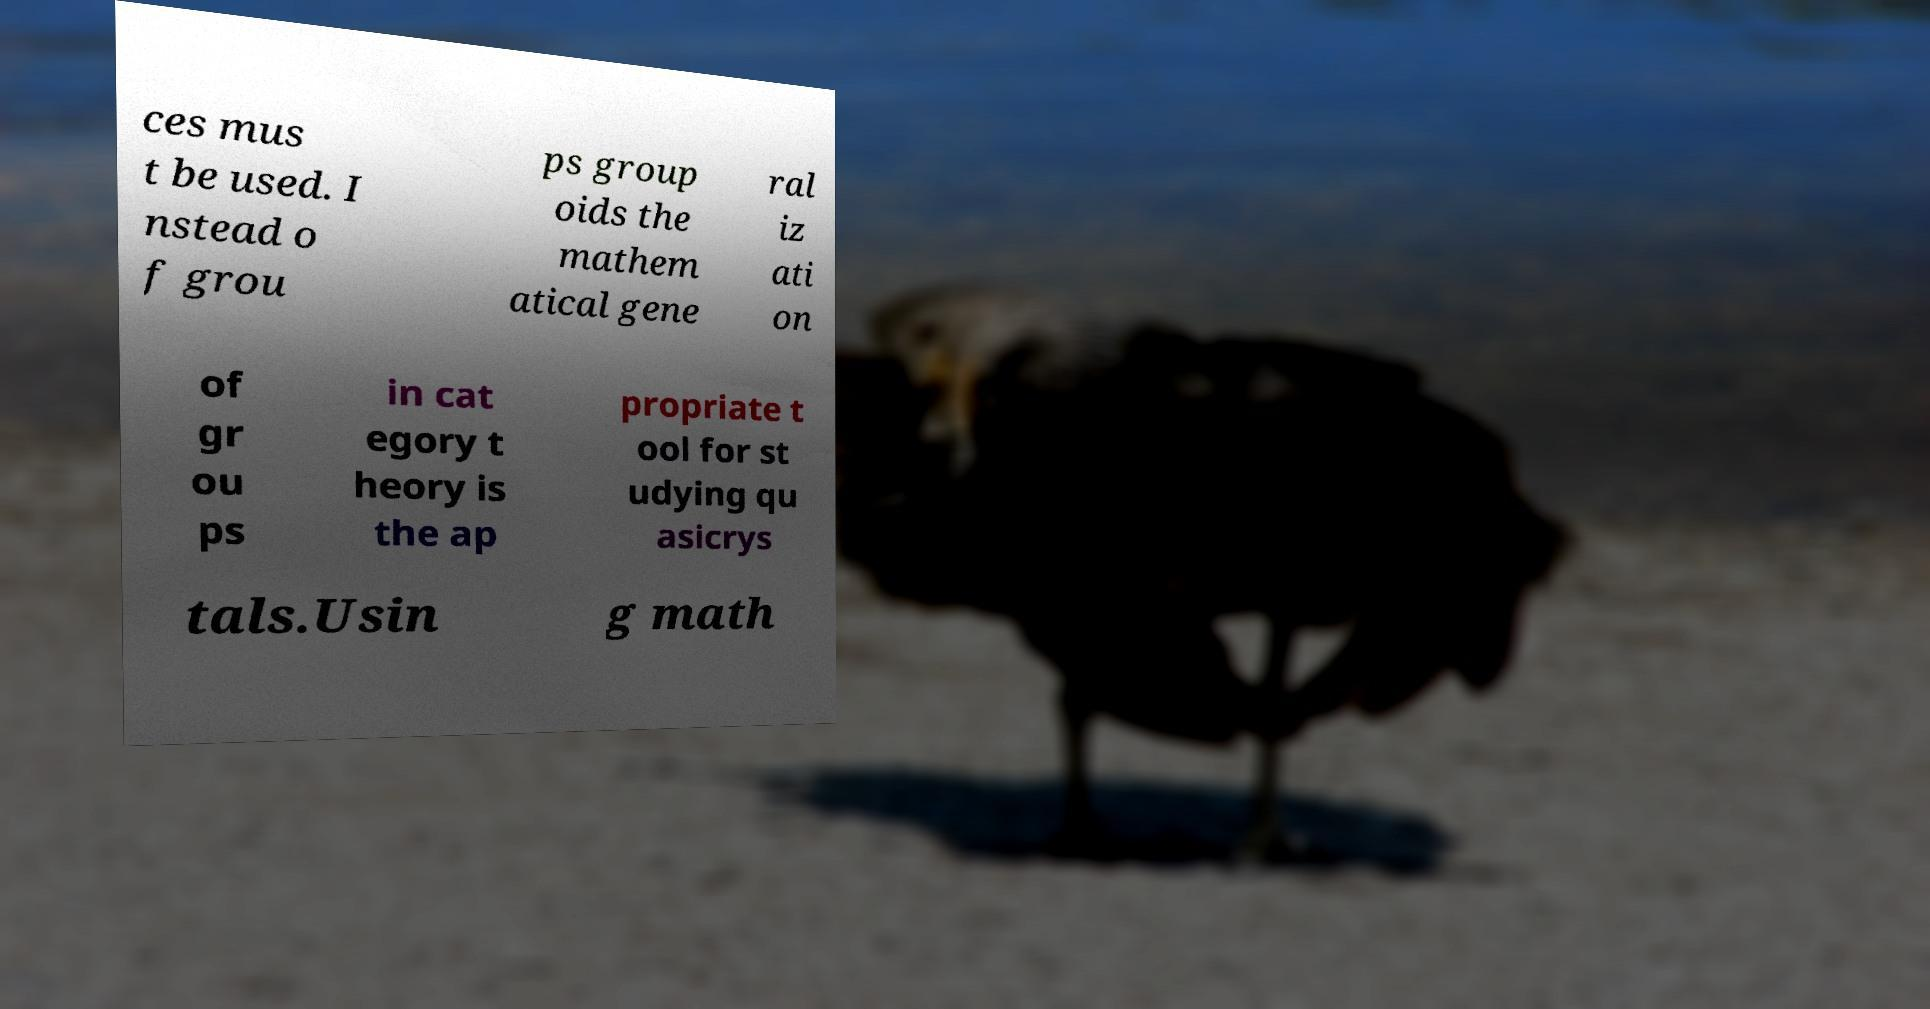Please read and relay the text visible in this image. What does it say? ces mus t be used. I nstead o f grou ps group oids the mathem atical gene ral iz ati on of gr ou ps in cat egory t heory is the ap propriate t ool for st udying qu asicrys tals.Usin g math 